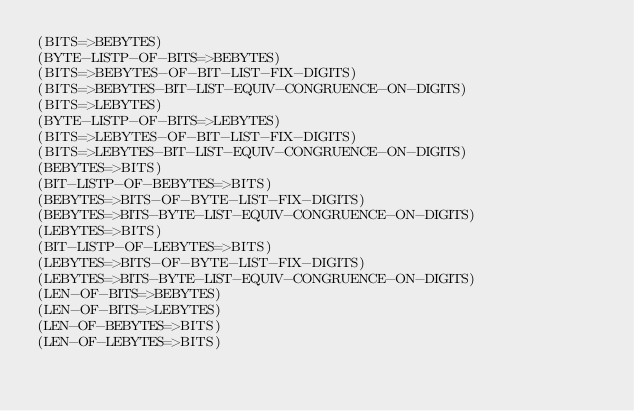<code> <loc_0><loc_0><loc_500><loc_500><_Lisp_>(BITS=>BEBYTES)
(BYTE-LISTP-OF-BITS=>BEBYTES)
(BITS=>BEBYTES-OF-BIT-LIST-FIX-DIGITS)
(BITS=>BEBYTES-BIT-LIST-EQUIV-CONGRUENCE-ON-DIGITS)
(BITS=>LEBYTES)
(BYTE-LISTP-OF-BITS=>LEBYTES)
(BITS=>LEBYTES-OF-BIT-LIST-FIX-DIGITS)
(BITS=>LEBYTES-BIT-LIST-EQUIV-CONGRUENCE-ON-DIGITS)
(BEBYTES=>BITS)
(BIT-LISTP-OF-BEBYTES=>BITS)
(BEBYTES=>BITS-OF-BYTE-LIST-FIX-DIGITS)
(BEBYTES=>BITS-BYTE-LIST-EQUIV-CONGRUENCE-ON-DIGITS)
(LEBYTES=>BITS)
(BIT-LISTP-OF-LEBYTES=>BITS)
(LEBYTES=>BITS-OF-BYTE-LIST-FIX-DIGITS)
(LEBYTES=>BITS-BYTE-LIST-EQUIV-CONGRUENCE-ON-DIGITS)
(LEN-OF-BITS=>BEBYTES)
(LEN-OF-BITS=>LEBYTES)
(LEN-OF-BEBYTES=>BITS)
(LEN-OF-LEBYTES=>BITS)
</code> 